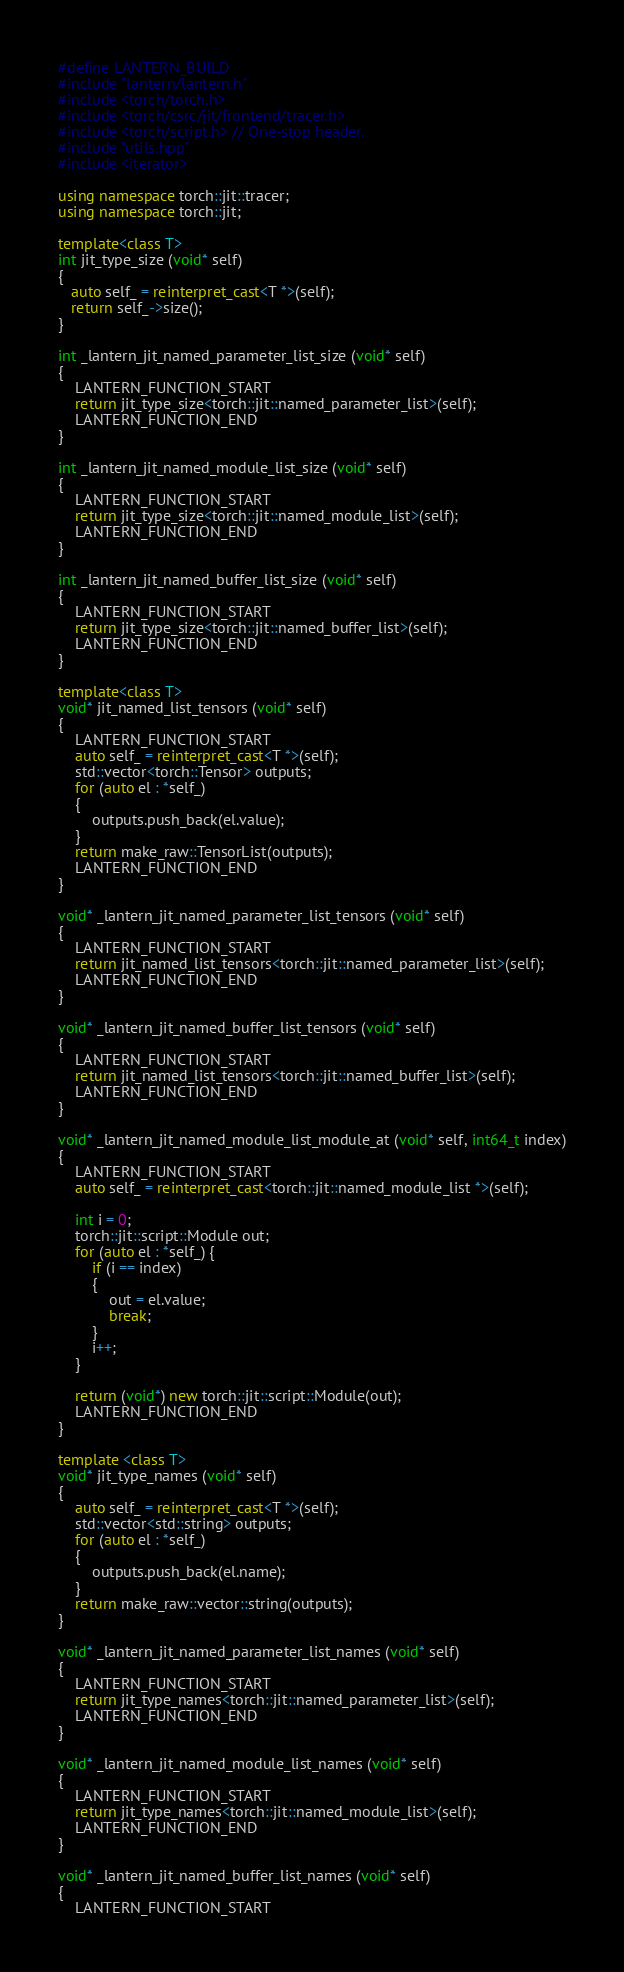Convert code to text. <code><loc_0><loc_0><loc_500><loc_500><_C++_>#define LANTERN_BUILD
#include "lantern/lantern.h"
#include <torch/torch.h>
#include <torch/csrc/jit/frontend/tracer.h>
#include <torch/script.h> // One-stop header.
#include "utils.hpp"
#include <iterator>

using namespace torch::jit::tracer;
using namespace torch::jit;

template<class T>
int jit_type_size (void* self)
{
   auto self_ = reinterpret_cast<T *>(self);
   return self_->size(); 
}

int _lantern_jit_named_parameter_list_size (void* self)
{
    LANTERN_FUNCTION_START
    return jit_type_size<torch::jit::named_parameter_list>(self);
    LANTERN_FUNCTION_END
}

int _lantern_jit_named_module_list_size (void* self)
{
    LANTERN_FUNCTION_START
    return jit_type_size<torch::jit::named_module_list>(self);
    LANTERN_FUNCTION_END
}

int _lantern_jit_named_buffer_list_size (void* self)
{
    LANTERN_FUNCTION_START
    return jit_type_size<torch::jit::named_buffer_list>(self);
    LANTERN_FUNCTION_END
}

template<class T>
void* jit_named_list_tensors (void* self)
{
    LANTERN_FUNCTION_START
    auto self_ = reinterpret_cast<T *>(self);
    std::vector<torch::Tensor> outputs;
    for (auto el : *self_)
    {
        outputs.push_back(el.value);
    }
    return make_raw::TensorList(outputs);
    LANTERN_FUNCTION_END
}

void* _lantern_jit_named_parameter_list_tensors (void* self)
{
    LANTERN_FUNCTION_START
    return jit_named_list_tensors<torch::jit::named_parameter_list>(self);
    LANTERN_FUNCTION_END
}

void* _lantern_jit_named_buffer_list_tensors (void* self)
{
    LANTERN_FUNCTION_START
    return jit_named_list_tensors<torch::jit::named_buffer_list>(self);
    LANTERN_FUNCTION_END
}

void* _lantern_jit_named_module_list_module_at (void* self, int64_t index)
{
    LANTERN_FUNCTION_START
    auto self_ = reinterpret_cast<torch::jit::named_module_list *>(self);
    
    int i = 0;
    torch::jit::script::Module out;
    for (auto el : *self_) {
        if (i == index)
        {
            out = el.value;
            break;
        }
        i++;    
    }

    return (void*) new torch::jit::script::Module(out);
    LANTERN_FUNCTION_END
}

template <class T>
void* jit_type_names (void* self)
{
    auto self_ = reinterpret_cast<T *>(self);
    std::vector<std::string> outputs;
    for (auto el : *self_)
    {
        outputs.push_back(el.name);
    }
    return make_raw::vector::string(outputs);
}

void* _lantern_jit_named_parameter_list_names (void* self)
{
    LANTERN_FUNCTION_START
    return jit_type_names<torch::jit::named_parameter_list>(self);
    LANTERN_FUNCTION_END
}

void* _lantern_jit_named_module_list_names (void* self)
{
    LANTERN_FUNCTION_START
    return jit_type_names<torch::jit::named_module_list>(self);
    LANTERN_FUNCTION_END
}

void* _lantern_jit_named_buffer_list_names (void* self)
{
    LANTERN_FUNCTION_START</code> 